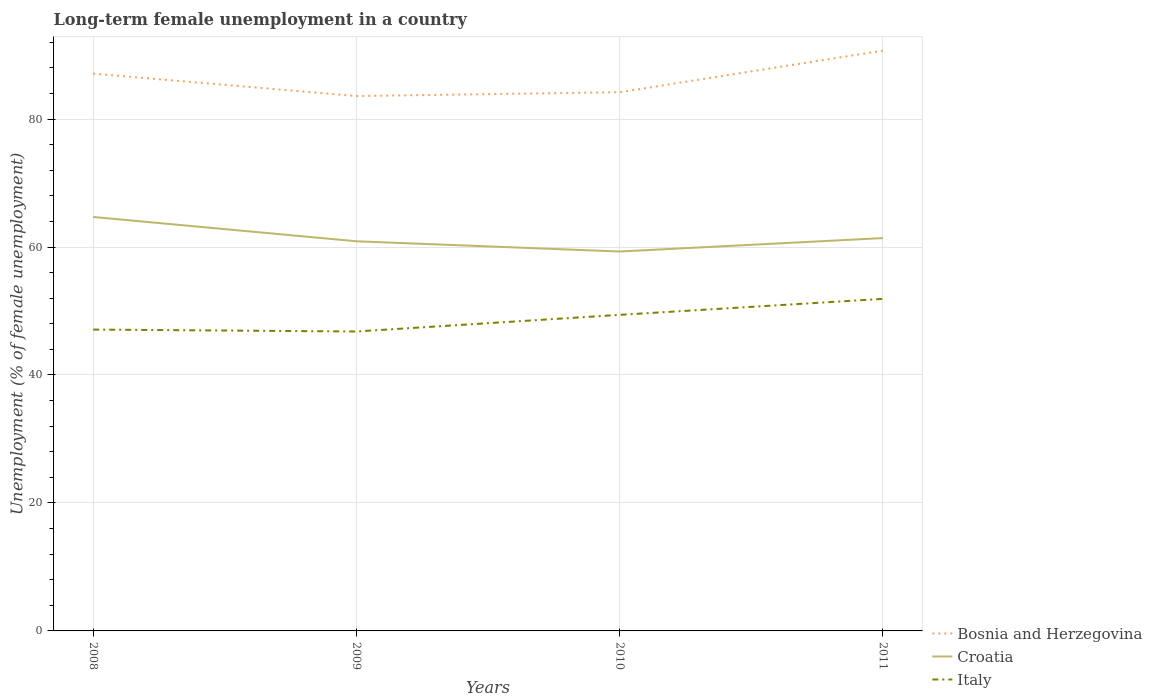Across all years, what is the maximum percentage of long-term unemployed female population in Croatia?
Your response must be concise. 59.3. In which year was the percentage of long-term unemployed female population in Bosnia and Herzegovina maximum?
Your answer should be very brief. 2009. What is the total percentage of long-term unemployed female population in Bosnia and Herzegovina in the graph?
Your answer should be very brief. -7.1. What is the difference between the highest and the second highest percentage of long-term unemployed female population in Croatia?
Provide a succinct answer. 5.4. Are the values on the major ticks of Y-axis written in scientific E-notation?
Keep it short and to the point. No. Where does the legend appear in the graph?
Your response must be concise. Bottom right. What is the title of the graph?
Give a very brief answer. Long-term female unemployment in a country. What is the label or title of the X-axis?
Your answer should be very brief. Years. What is the label or title of the Y-axis?
Ensure brevity in your answer.  Unemployment (% of female unemployment). What is the Unemployment (% of female unemployment) in Bosnia and Herzegovina in 2008?
Your response must be concise. 87.1. What is the Unemployment (% of female unemployment) in Croatia in 2008?
Ensure brevity in your answer.  64.7. What is the Unemployment (% of female unemployment) of Italy in 2008?
Give a very brief answer. 47.1. What is the Unemployment (% of female unemployment) in Bosnia and Herzegovina in 2009?
Keep it short and to the point. 83.6. What is the Unemployment (% of female unemployment) of Croatia in 2009?
Ensure brevity in your answer.  60.9. What is the Unemployment (% of female unemployment) in Italy in 2009?
Offer a very short reply. 46.8. What is the Unemployment (% of female unemployment) of Bosnia and Herzegovina in 2010?
Provide a short and direct response. 84.2. What is the Unemployment (% of female unemployment) in Croatia in 2010?
Provide a succinct answer. 59.3. What is the Unemployment (% of female unemployment) in Italy in 2010?
Make the answer very short. 49.4. What is the Unemployment (% of female unemployment) in Bosnia and Herzegovina in 2011?
Give a very brief answer. 90.7. What is the Unemployment (% of female unemployment) of Croatia in 2011?
Give a very brief answer. 61.4. What is the Unemployment (% of female unemployment) in Italy in 2011?
Offer a very short reply. 51.9. Across all years, what is the maximum Unemployment (% of female unemployment) in Bosnia and Herzegovina?
Your answer should be very brief. 90.7. Across all years, what is the maximum Unemployment (% of female unemployment) of Croatia?
Offer a terse response. 64.7. Across all years, what is the maximum Unemployment (% of female unemployment) of Italy?
Your answer should be compact. 51.9. Across all years, what is the minimum Unemployment (% of female unemployment) of Bosnia and Herzegovina?
Ensure brevity in your answer.  83.6. Across all years, what is the minimum Unemployment (% of female unemployment) of Croatia?
Keep it short and to the point. 59.3. Across all years, what is the minimum Unemployment (% of female unemployment) of Italy?
Your answer should be very brief. 46.8. What is the total Unemployment (% of female unemployment) of Bosnia and Herzegovina in the graph?
Make the answer very short. 345.6. What is the total Unemployment (% of female unemployment) in Croatia in the graph?
Provide a short and direct response. 246.3. What is the total Unemployment (% of female unemployment) in Italy in the graph?
Make the answer very short. 195.2. What is the difference between the Unemployment (% of female unemployment) in Bosnia and Herzegovina in 2008 and that in 2009?
Your response must be concise. 3.5. What is the difference between the Unemployment (% of female unemployment) of Croatia in 2008 and that in 2009?
Provide a succinct answer. 3.8. What is the difference between the Unemployment (% of female unemployment) of Italy in 2008 and that in 2009?
Provide a short and direct response. 0.3. What is the difference between the Unemployment (% of female unemployment) of Croatia in 2008 and that in 2010?
Your answer should be very brief. 5.4. What is the difference between the Unemployment (% of female unemployment) in Bosnia and Herzegovina in 2008 and that in 2011?
Your response must be concise. -3.6. What is the difference between the Unemployment (% of female unemployment) in Bosnia and Herzegovina in 2009 and that in 2010?
Give a very brief answer. -0.6. What is the difference between the Unemployment (% of female unemployment) in Bosnia and Herzegovina in 2009 and that in 2011?
Keep it short and to the point. -7.1. What is the difference between the Unemployment (% of female unemployment) in Bosnia and Herzegovina in 2008 and the Unemployment (% of female unemployment) in Croatia in 2009?
Offer a very short reply. 26.2. What is the difference between the Unemployment (% of female unemployment) of Bosnia and Herzegovina in 2008 and the Unemployment (% of female unemployment) of Italy in 2009?
Provide a succinct answer. 40.3. What is the difference between the Unemployment (% of female unemployment) in Croatia in 2008 and the Unemployment (% of female unemployment) in Italy in 2009?
Offer a very short reply. 17.9. What is the difference between the Unemployment (% of female unemployment) of Bosnia and Herzegovina in 2008 and the Unemployment (% of female unemployment) of Croatia in 2010?
Make the answer very short. 27.8. What is the difference between the Unemployment (% of female unemployment) of Bosnia and Herzegovina in 2008 and the Unemployment (% of female unemployment) of Italy in 2010?
Offer a very short reply. 37.7. What is the difference between the Unemployment (% of female unemployment) in Croatia in 2008 and the Unemployment (% of female unemployment) in Italy in 2010?
Your answer should be very brief. 15.3. What is the difference between the Unemployment (% of female unemployment) of Bosnia and Herzegovina in 2008 and the Unemployment (% of female unemployment) of Croatia in 2011?
Make the answer very short. 25.7. What is the difference between the Unemployment (% of female unemployment) of Bosnia and Herzegovina in 2008 and the Unemployment (% of female unemployment) of Italy in 2011?
Ensure brevity in your answer.  35.2. What is the difference between the Unemployment (% of female unemployment) of Bosnia and Herzegovina in 2009 and the Unemployment (% of female unemployment) of Croatia in 2010?
Your response must be concise. 24.3. What is the difference between the Unemployment (% of female unemployment) in Bosnia and Herzegovina in 2009 and the Unemployment (% of female unemployment) in Italy in 2010?
Provide a succinct answer. 34.2. What is the difference between the Unemployment (% of female unemployment) in Bosnia and Herzegovina in 2009 and the Unemployment (% of female unemployment) in Croatia in 2011?
Offer a terse response. 22.2. What is the difference between the Unemployment (% of female unemployment) of Bosnia and Herzegovina in 2009 and the Unemployment (% of female unemployment) of Italy in 2011?
Your response must be concise. 31.7. What is the difference between the Unemployment (% of female unemployment) in Bosnia and Herzegovina in 2010 and the Unemployment (% of female unemployment) in Croatia in 2011?
Ensure brevity in your answer.  22.8. What is the difference between the Unemployment (% of female unemployment) of Bosnia and Herzegovina in 2010 and the Unemployment (% of female unemployment) of Italy in 2011?
Your answer should be compact. 32.3. What is the average Unemployment (% of female unemployment) in Bosnia and Herzegovina per year?
Your answer should be compact. 86.4. What is the average Unemployment (% of female unemployment) in Croatia per year?
Your answer should be very brief. 61.58. What is the average Unemployment (% of female unemployment) in Italy per year?
Your answer should be compact. 48.8. In the year 2008, what is the difference between the Unemployment (% of female unemployment) in Bosnia and Herzegovina and Unemployment (% of female unemployment) in Croatia?
Your answer should be very brief. 22.4. In the year 2009, what is the difference between the Unemployment (% of female unemployment) in Bosnia and Herzegovina and Unemployment (% of female unemployment) in Croatia?
Ensure brevity in your answer.  22.7. In the year 2009, what is the difference between the Unemployment (% of female unemployment) in Bosnia and Herzegovina and Unemployment (% of female unemployment) in Italy?
Give a very brief answer. 36.8. In the year 2009, what is the difference between the Unemployment (% of female unemployment) in Croatia and Unemployment (% of female unemployment) in Italy?
Your answer should be compact. 14.1. In the year 2010, what is the difference between the Unemployment (% of female unemployment) in Bosnia and Herzegovina and Unemployment (% of female unemployment) in Croatia?
Your response must be concise. 24.9. In the year 2010, what is the difference between the Unemployment (% of female unemployment) in Bosnia and Herzegovina and Unemployment (% of female unemployment) in Italy?
Make the answer very short. 34.8. In the year 2010, what is the difference between the Unemployment (% of female unemployment) of Croatia and Unemployment (% of female unemployment) of Italy?
Provide a succinct answer. 9.9. In the year 2011, what is the difference between the Unemployment (% of female unemployment) in Bosnia and Herzegovina and Unemployment (% of female unemployment) in Croatia?
Offer a terse response. 29.3. In the year 2011, what is the difference between the Unemployment (% of female unemployment) of Bosnia and Herzegovina and Unemployment (% of female unemployment) of Italy?
Offer a terse response. 38.8. In the year 2011, what is the difference between the Unemployment (% of female unemployment) of Croatia and Unemployment (% of female unemployment) of Italy?
Your response must be concise. 9.5. What is the ratio of the Unemployment (% of female unemployment) of Bosnia and Herzegovina in 2008 to that in 2009?
Your answer should be very brief. 1.04. What is the ratio of the Unemployment (% of female unemployment) in Croatia in 2008 to that in 2009?
Provide a succinct answer. 1.06. What is the ratio of the Unemployment (% of female unemployment) of Italy in 2008 to that in 2009?
Offer a very short reply. 1.01. What is the ratio of the Unemployment (% of female unemployment) in Bosnia and Herzegovina in 2008 to that in 2010?
Make the answer very short. 1.03. What is the ratio of the Unemployment (% of female unemployment) in Croatia in 2008 to that in 2010?
Ensure brevity in your answer.  1.09. What is the ratio of the Unemployment (% of female unemployment) of Italy in 2008 to that in 2010?
Your answer should be very brief. 0.95. What is the ratio of the Unemployment (% of female unemployment) of Bosnia and Herzegovina in 2008 to that in 2011?
Keep it short and to the point. 0.96. What is the ratio of the Unemployment (% of female unemployment) in Croatia in 2008 to that in 2011?
Provide a succinct answer. 1.05. What is the ratio of the Unemployment (% of female unemployment) in Italy in 2008 to that in 2011?
Provide a short and direct response. 0.91. What is the ratio of the Unemployment (% of female unemployment) in Bosnia and Herzegovina in 2009 to that in 2011?
Provide a short and direct response. 0.92. What is the ratio of the Unemployment (% of female unemployment) of Italy in 2009 to that in 2011?
Offer a very short reply. 0.9. What is the ratio of the Unemployment (% of female unemployment) of Bosnia and Herzegovina in 2010 to that in 2011?
Make the answer very short. 0.93. What is the ratio of the Unemployment (% of female unemployment) of Croatia in 2010 to that in 2011?
Your answer should be compact. 0.97. What is the ratio of the Unemployment (% of female unemployment) of Italy in 2010 to that in 2011?
Provide a succinct answer. 0.95. What is the difference between the highest and the second highest Unemployment (% of female unemployment) in Bosnia and Herzegovina?
Keep it short and to the point. 3.6. What is the difference between the highest and the second highest Unemployment (% of female unemployment) of Italy?
Your response must be concise. 2.5. 